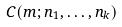<formula> <loc_0><loc_0><loc_500><loc_500>C ( m ; n _ { 1 } , \dots , n _ { k } )</formula> 